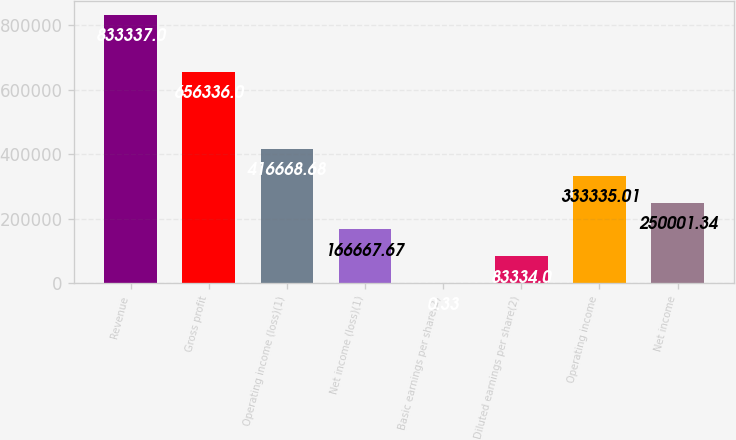<chart> <loc_0><loc_0><loc_500><loc_500><bar_chart><fcel>Revenue<fcel>Gross profit<fcel>Operating income (loss)(1)<fcel>Net income (loss)(1)<fcel>Basic earnings per share(2)<fcel>Diluted earnings per share(2)<fcel>Operating income<fcel>Net income<nl><fcel>833337<fcel>656336<fcel>416669<fcel>166668<fcel>0.33<fcel>83334<fcel>333335<fcel>250001<nl></chart> 